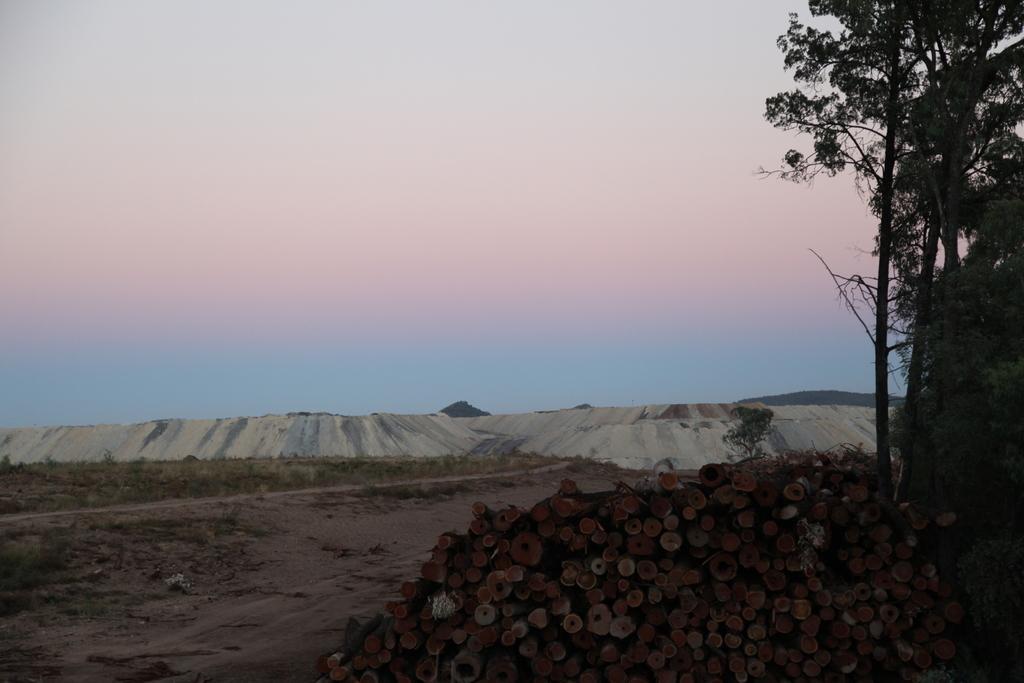Can you describe this image briefly? This picture is clicked outside. In the foreground we can see some wooden objects and the trees. In the background, we can see the sky, hills, grass and some white particles seems to be the snow. 